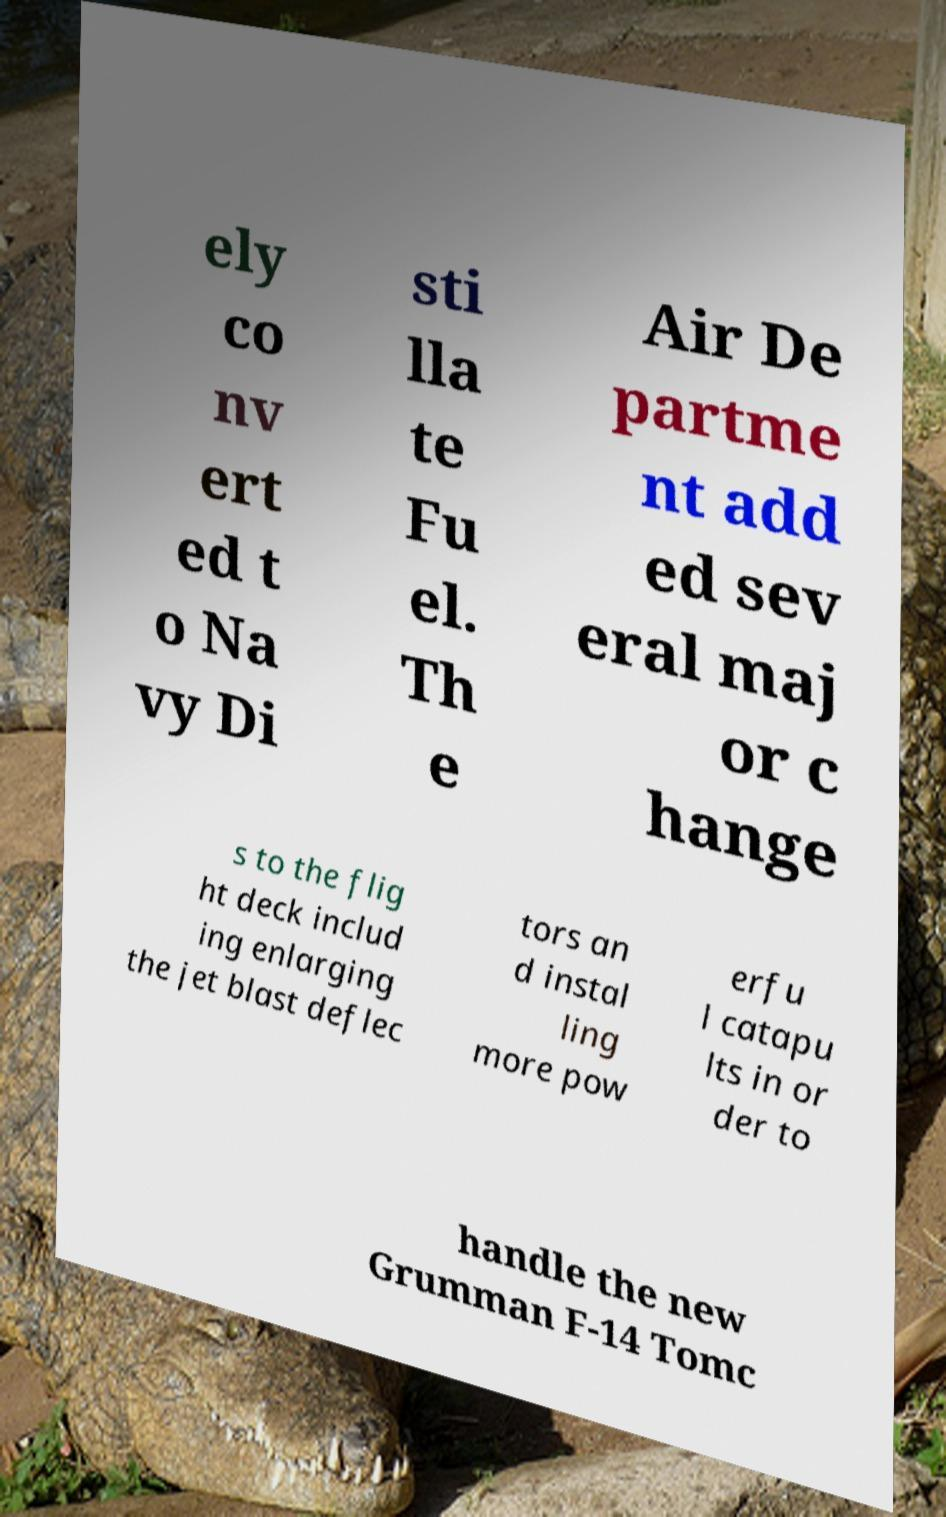Can you read and provide the text displayed in the image?This photo seems to have some interesting text. Can you extract and type it out for me? ely co nv ert ed t o Na vy Di sti lla te Fu el. Th e Air De partme nt add ed sev eral maj or c hange s to the flig ht deck includ ing enlarging the jet blast deflec tors an d instal ling more pow erfu l catapu lts in or der to handle the new Grumman F-14 Tomc 